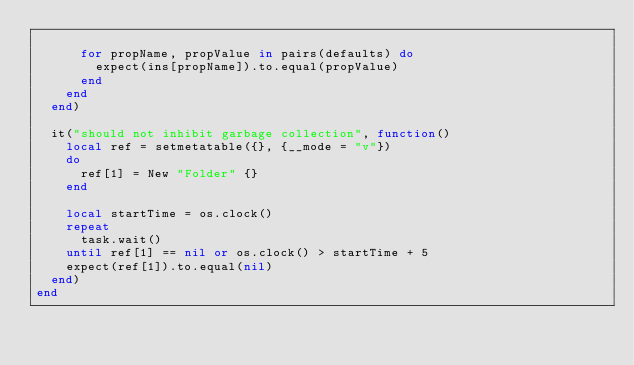<code> <loc_0><loc_0><loc_500><loc_500><_Lua_>
			for propName, propValue in pairs(defaults) do
				expect(ins[propName]).to.equal(propValue)
			end
		end
	end)

	it("should not inhibit garbage collection", function()
		local ref = setmetatable({}, {__mode = "v"})
		do
			ref[1] = New "Folder" {}
		end

		local startTime = os.clock()
		repeat
			task.wait()
		until ref[1] == nil or os.clock() > startTime + 5
		expect(ref[1]).to.equal(nil)
	end)
end</code> 